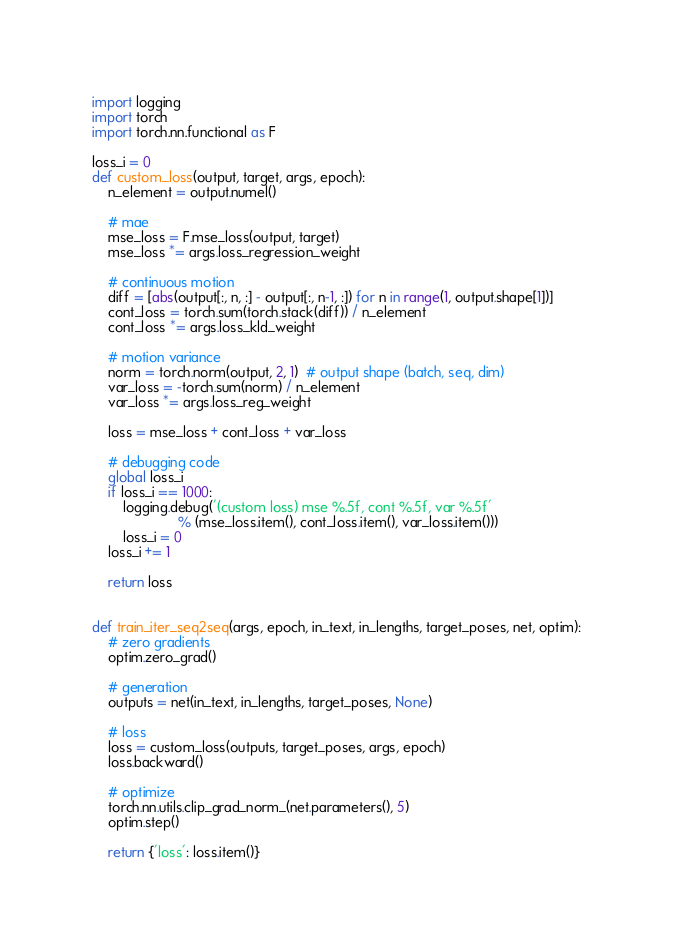<code> <loc_0><loc_0><loc_500><loc_500><_Python_>import logging
import torch
import torch.nn.functional as F

loss_i = 0
def custom_loss(output, target, args, epoch):
    n_element = output.numel()

    # mae
    mse_loss = F.mse_loss(output, target)
    mse_loss *= args.loss_regression_weight

    # continuous motion
    diff = [abs(output[:, n, :] - output[:, n-1, :]) for n in range(1, output.shape[1])]
    cont_loss = torch.sum(torch.stack(diff)) / n_element
    cont_loss *= args.loss_kld_weight

    # motion variance
    norm = torch.norm(output, 2, 1)  # output shape (batch, seq, dim)
    var_loss = -torch.sum(norm) / n_element
    var_loss *= args.loss_reg_weight

    loss = mse_loss + cont_loss + var_loss

    # debugging code
    global loss_i
    if loss_i == 1000:
        logging.debug('(custom loss) mse %.5f, cont %.5f, var %.5f'
                      % (mse_loss.item(), cont_loss.item(), var_loss.item()))
        loss_i = 0
    loss_i += 1

    return loss


def train_iter_seq2seq(args, epoch, in_text, in_lengths, target_poses, net, optim):
    # zero gradients
    optim.zero_grad()

    # generation
    outputs = net(in_text, in_lengths, target_poses, None)

    # loss
    loss = custom_loss(outputs, target_poses, args, epoch)
    loss.backward()

    # optimize
    torch.nn.utils.clip_grad_norm_(net.parameters(), 5)
    optim.step()

    return {'loss': loss.item()}
</code> 